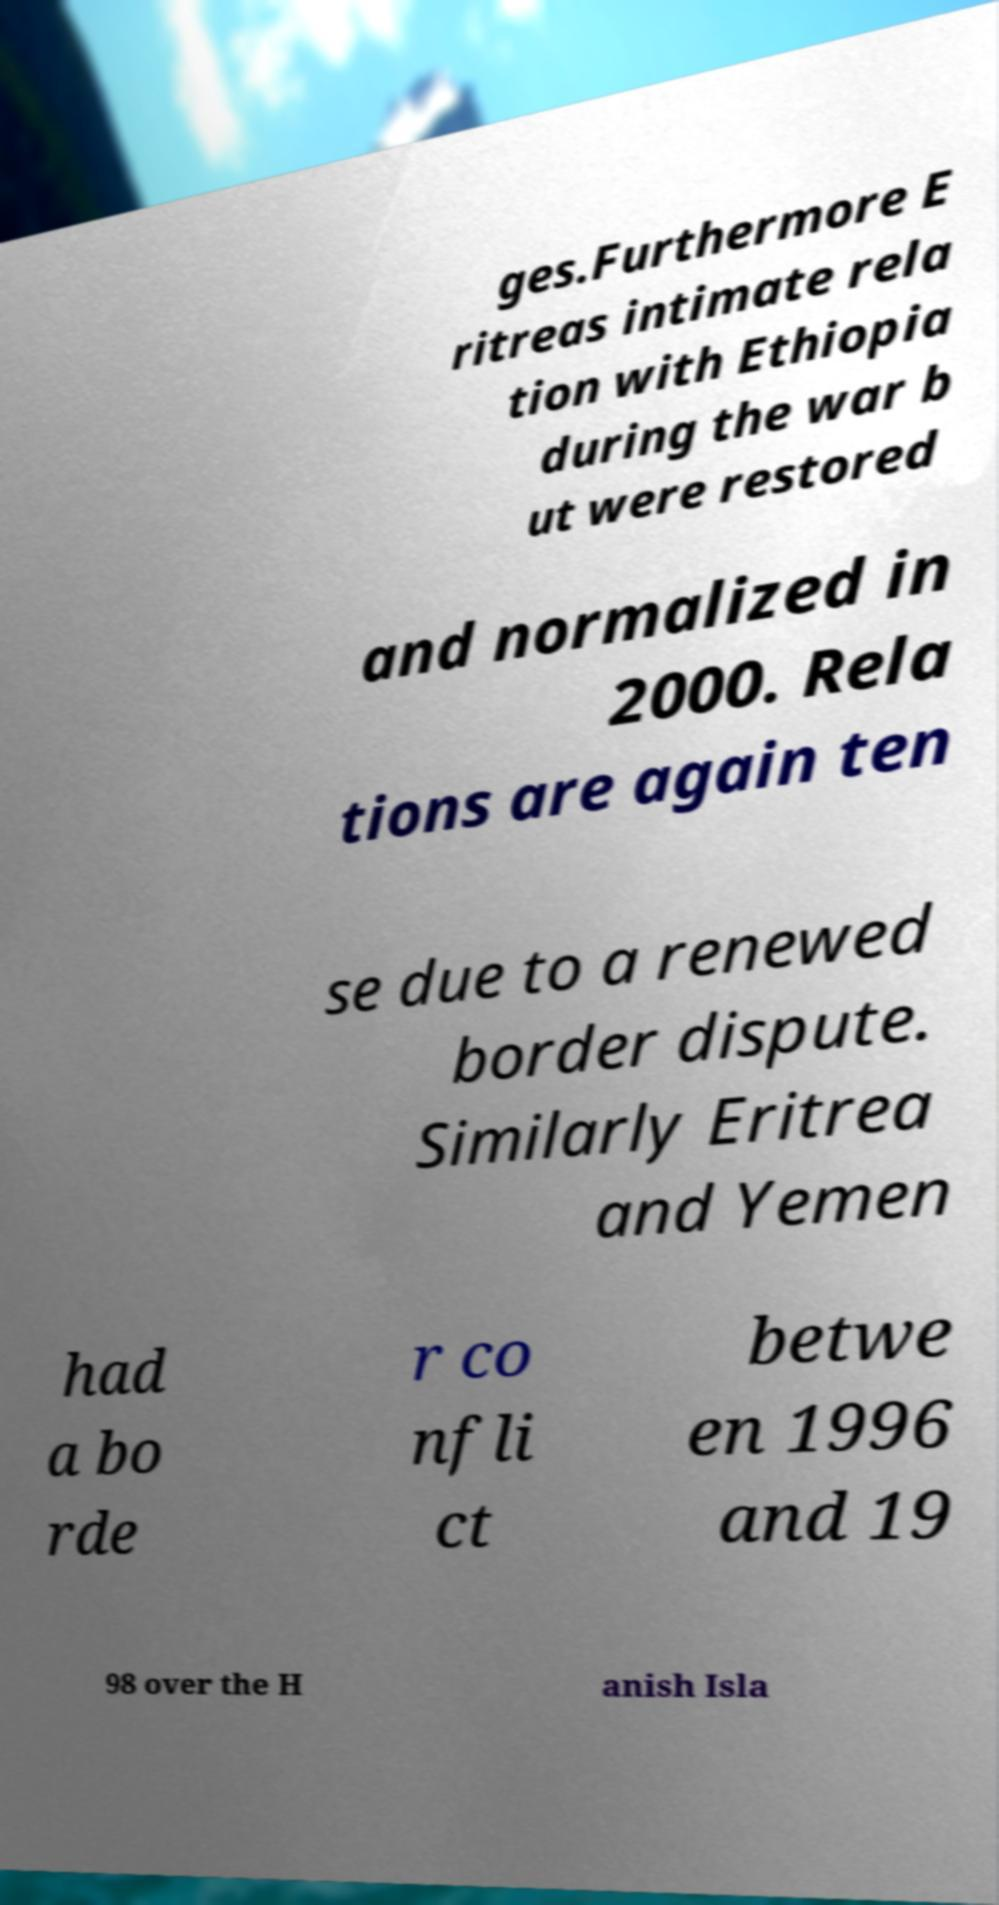I need the written content from this picture converted into text. Can you do that? ges.Furthermore E ritreas intimate rela tion with Ethiopia during the war b ut were restored and normalized in 2000. Rela tions are again ten se due to a renewed border dispute. Similarly Eritrea and Yemen had a bo rde r co nfli ct betwe en 1996 and 19 98 over the H anish Isla 